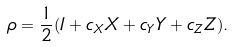<formula> <loc_0><loc_0><loc_500><loc_500>\rho = \frac { 1 } { 2 } ( I + c _ { X } X + c _ { Y } Y + c _ { Z } Z ) .</formula> 